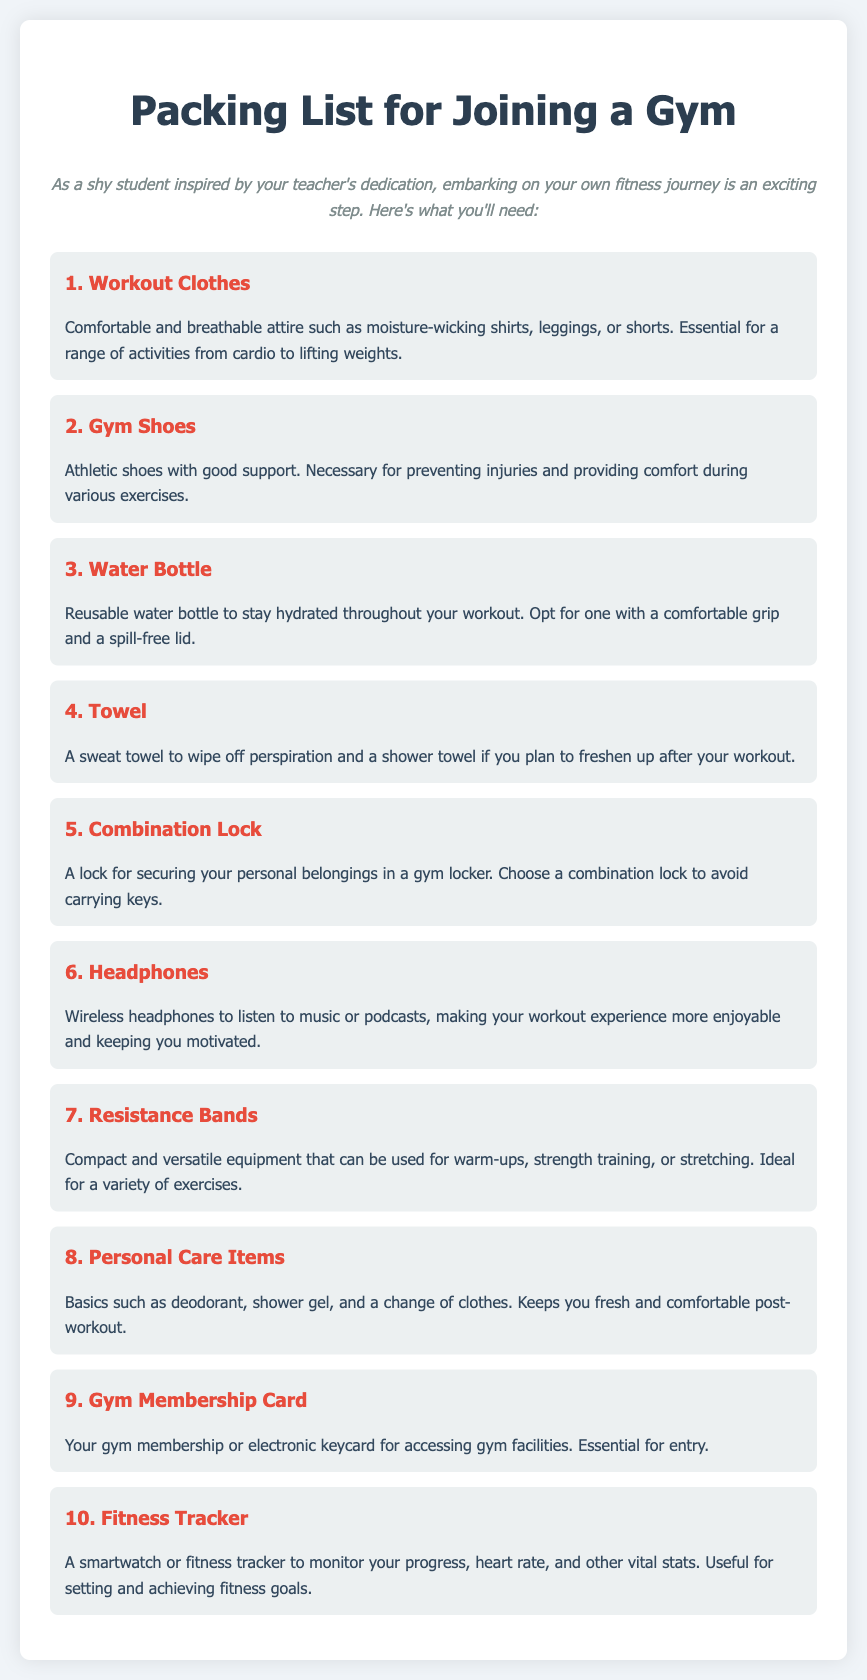What is the title of the document? The title of the document is prominently displayed at the top of the page as "Packing List for Joining a Gym."
Answer: Packing List for Joining a Gym How many items are listed in the packing list? The document outlines a total of ten essential items needed for joining a gym.
Answer: 10 What should you bring to stay hydrated? The item specifically mentioned for hydration is the reusable water bottle.
Answer: Water Bottle What type of item is used for monitoring progress? The document mentions a gadget that can track fitness metrics is a fitness tracker.
Answer: Fitness Tracker What is essential for securing personal belongings? The packing list highlights the necessity of a lock for securing items in a gym locker.
Answer: Combination Lock Why might someone want to use wireless headphones? The document states that wireless headphones make the workout experience more enjoyable and motivating.
Answer: To enjoy music or podcasts Which clothing item is suggested for comfort during workouts? The recommended clothing item for comfort is workout clothes, particularly moisture-wicking attire.
Answer: Workout Clothes What items are included in personal care items? The document refers to basics such as deodorant and shower gel included in personal care items.
Answer: Deodorant, shower gel What is the benefit of using resistance bands? The document highlights resistance bands as compact equipment ideal for various exercises.
Answer: Compact and versatile equipment What item is necessary for gym entry? The gym membership card or electronic keycard is essential for accessing gym facilities.
Answer: Gym Membership Card 